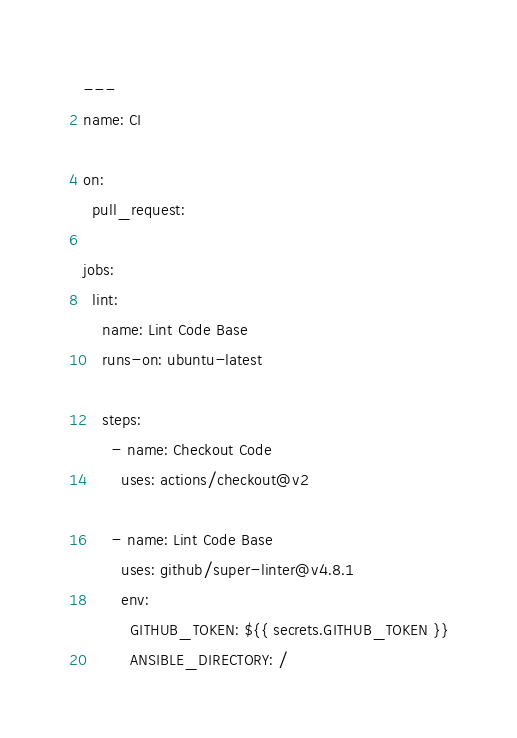<code> <loc_0><loc_0><loc_500><loc_500><_YAML_>---
name: CI

on:
  pull_request:

jobs:
  lint:
    name: Lint Code Base
    runs-on: ubuntu-latest

    steps:
      - name: Checkout Code
        uses: actions/checkout@v2

      - name: Lint Code Base
        uses: github/super-linter@v4.8.1
        env:
          GITHUB_TOKEN: ${{ secrets.GITHUB_TOKEN }}
          ANSIBLE_DIRECTORY: /
</code> 